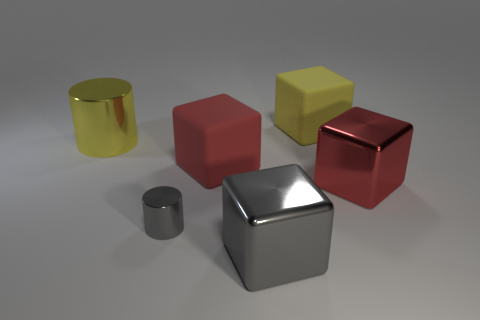Add 1 yellow rubber blocks. How many objects exist? 7 Subtract all cylinders. How many objects are left? 4 Add 3 yellow rubber things. How many yellow rubber things exist? 4 Subtract 0 brown cylinders. How many objects are left? 6 Subtract all large red rubber things. Subtract all large yellow rubber objects. How many objects are left? 4 Add 6 yellow matte objects. How many yellow matte objects are left? 7 